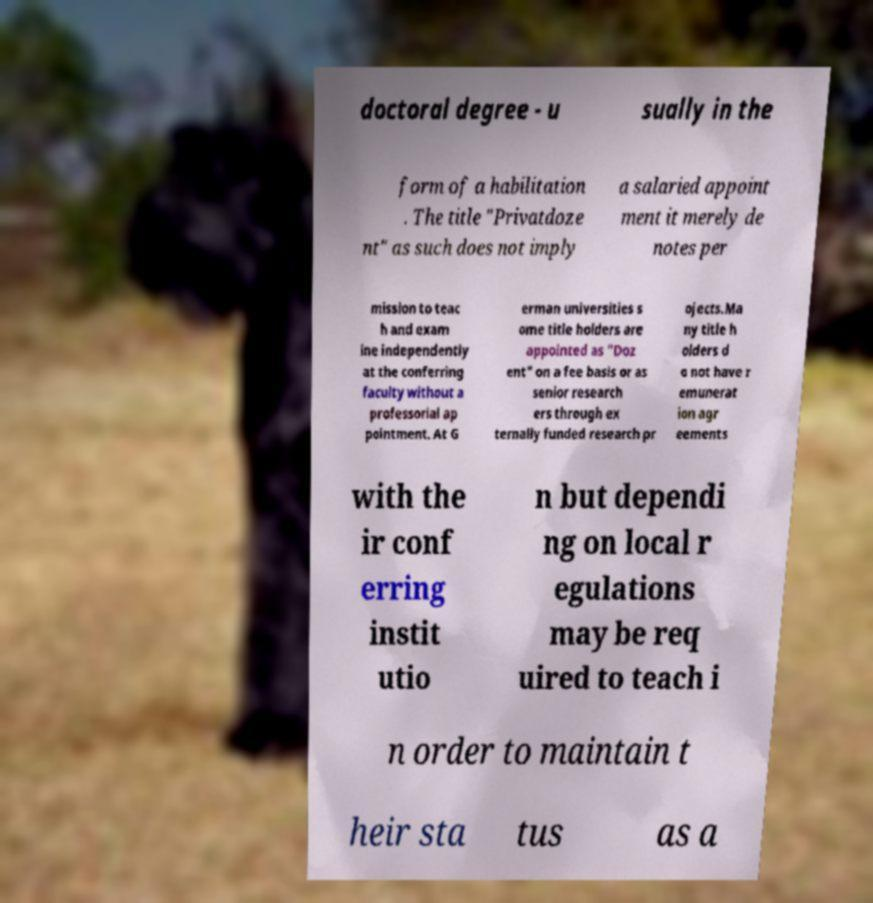I need the written content from this picture converted into text. Can you do that? doctoral degree - u sually in the form of a habilitation . The title "Privatdoze nt" as such does not imply a salaried appoint ment it merely de notes per mission to teac h and exam ine independently at the conferring faculty without a professorial ap pointment. At G erman universities s ome title holders are appointed as "Doz ent" on a fee basis or as senior research ers through ex ternally funded research pr ojects.Ma ny title h olders d o not have r emunerat ion agr eements with the ir conf erring instit utio n but dependi ng on local r egulations may be req uired to teach i n order to maintain t heir sta tus as a 